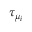Convert formula to latex. <formula><loc_0><loc_0><loc_500><loc_500>\tau _ { \mu _ { i } }</formula> 